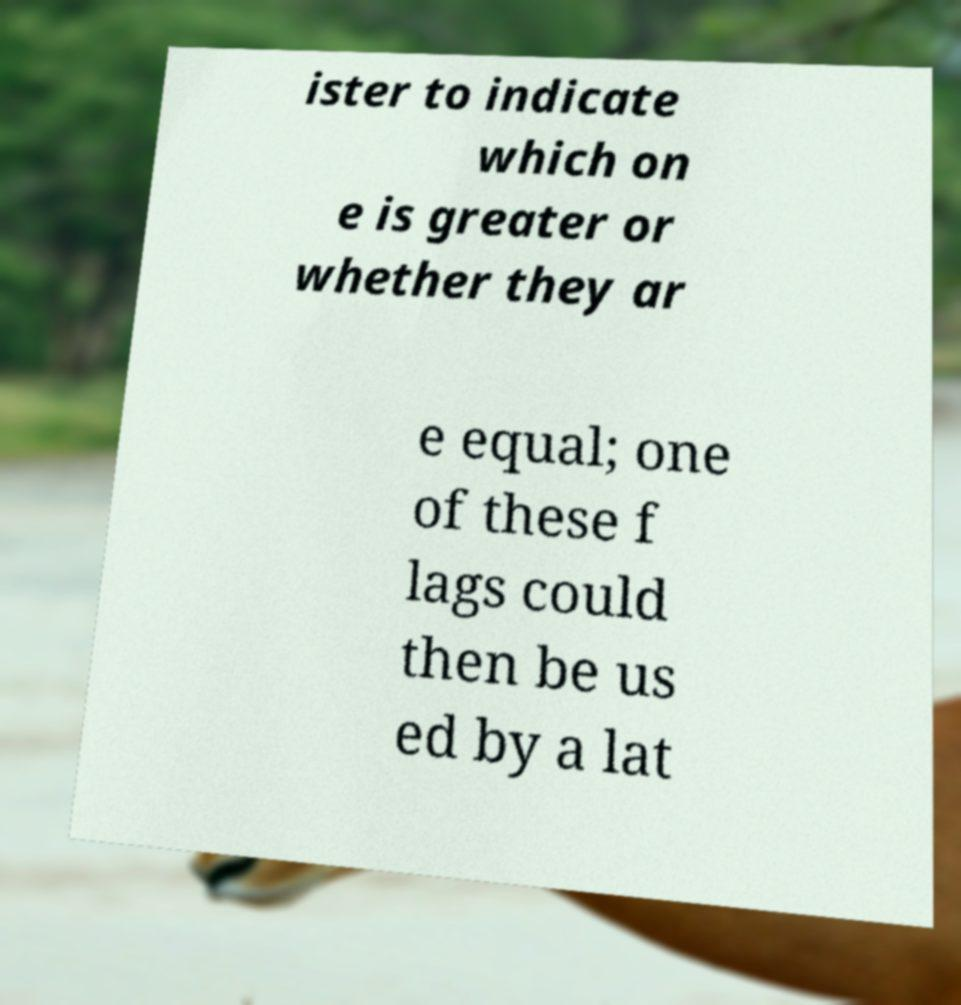Could you assist in decoding the text presented in this image and type it out clearly? ister to indicate which on e is greater or whether they ar e equal; one of these f lags could then be us ed by a lat 